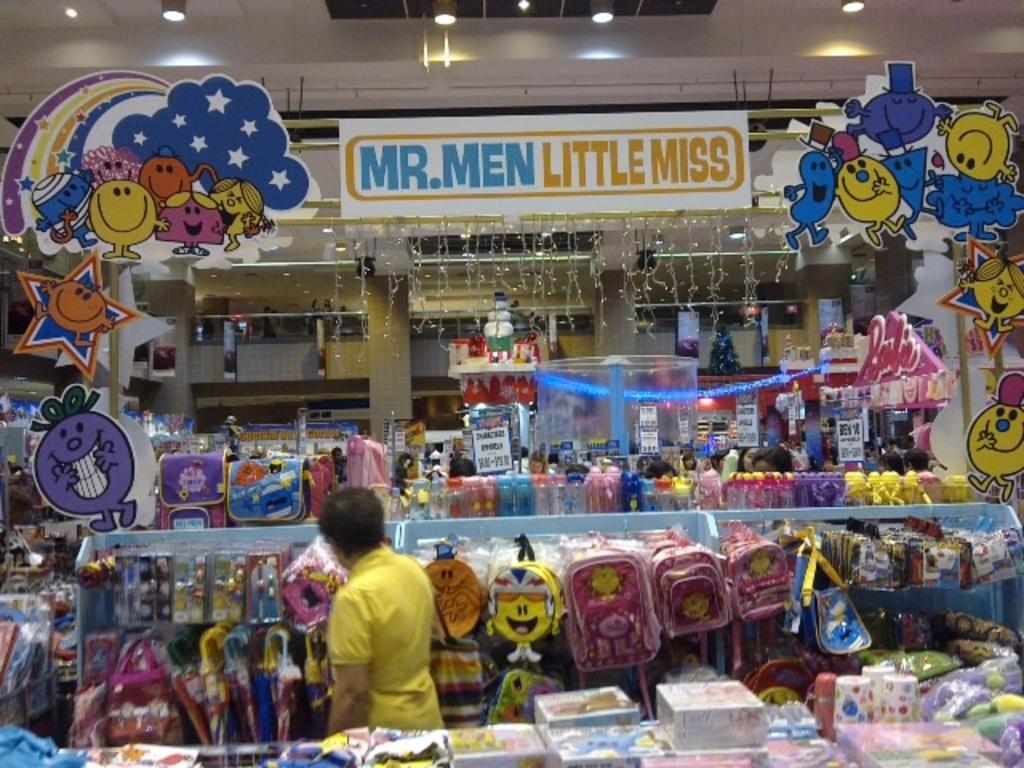What are the words in yellow?
Provide a succinct answer. Little miss. What cartoon is shown in the blue text?
Give a very brief answer. Mr. men. 